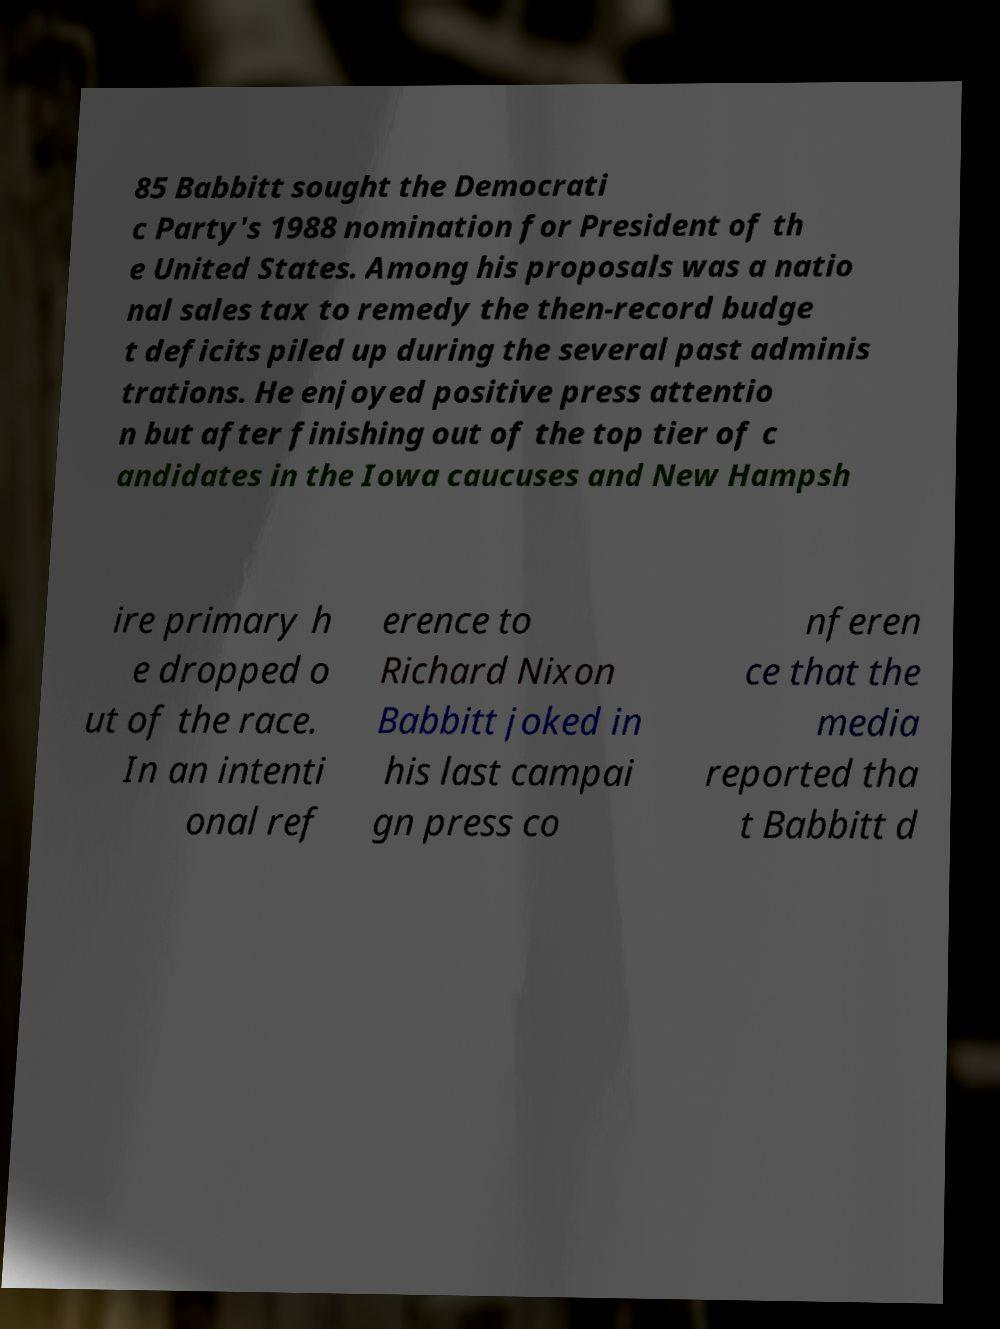Could you assist in decoding the text presented in this image and type it out clearly? 85 Babbitt sought the Democrati c Party's 1988 nomination for President of th e United States. Among his proposals was a natio nal sales tax to remedy the then-record budge t deficits piled up during the several past adminis trations. He enjoyed positive press attentio n but after finishing out of the top tier of c andidates in the Iowa caucuses and New Hampsh ire primary h e dropped o ut of the race. In an intenti onal ref erence to Richard Nixon Babbitt joked in his last campai gn press co nferen ce that the media reported tha t Babbitt d 